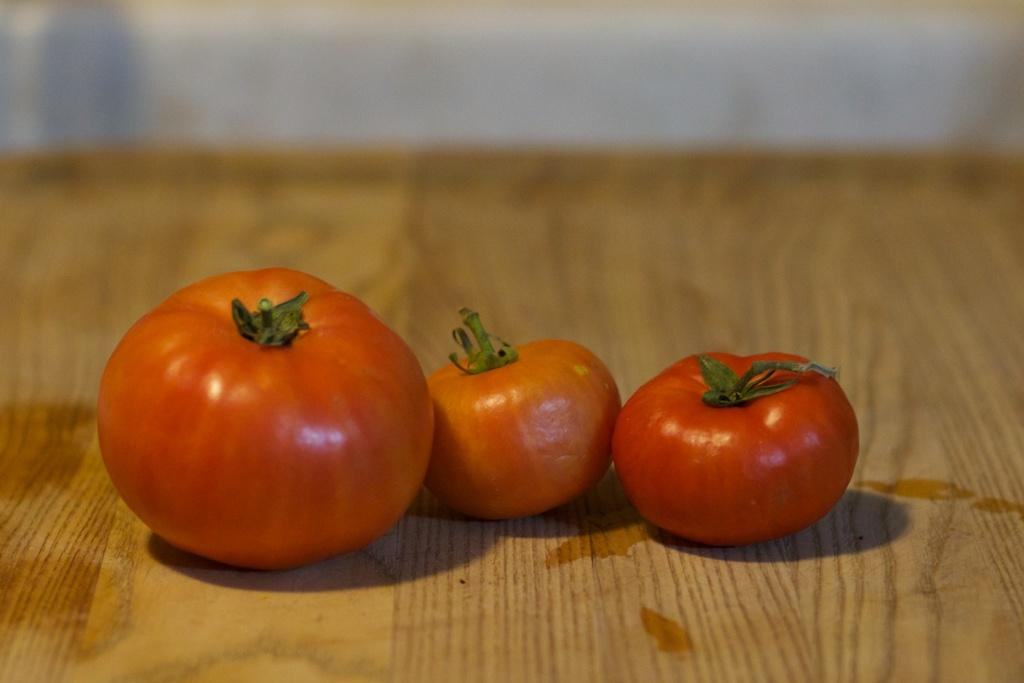What objects are present on the wooden surface in the image? There are three tomatoes on a wooden surface in the image. Can you describe the background of the image? The background of the image is blurred. What type of bomb can be seen in the image? There is no bomb present in the image; it features three tomatoes on a wooden surface. How many mouths are visible in the image? There are no mouths visible in the image. 